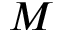<formula> <loc_0><loc_0><loc_500><loc_500>M</formula> 